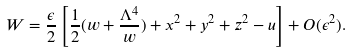Convert formula to latex. <formula><loc_0><loc_0><loc_500><loc_500>W = \frac { \epsilon } 2 \left [ \frac { 1 } { 2 } ( w + \frac { \Lambda ^ { 4 } } { w } ) + x ^ { 2 } + y ^ { 2 } + z ^ { 2 } - u \right ] + O ( \epsilon ^ { 2 } ) .</formula> 